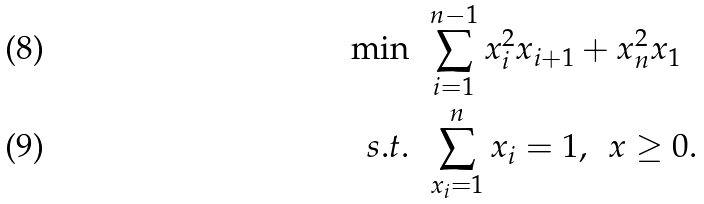<formula> <loc_0><loc_0><loc_500><loc_500>\min & \, \ \sum _ { i = 1 } ^ { n - 1 } x _ { i } ^ { 2 } x _ { i + 1 } + x _ { n } ^ { 2 } x _ { 1 } \\ s . t . & \, \ \sum _ { x _ { i } = 1 } ^ { n } x _ { i } = 1 , \, \ x \geq 0 .</formula> 